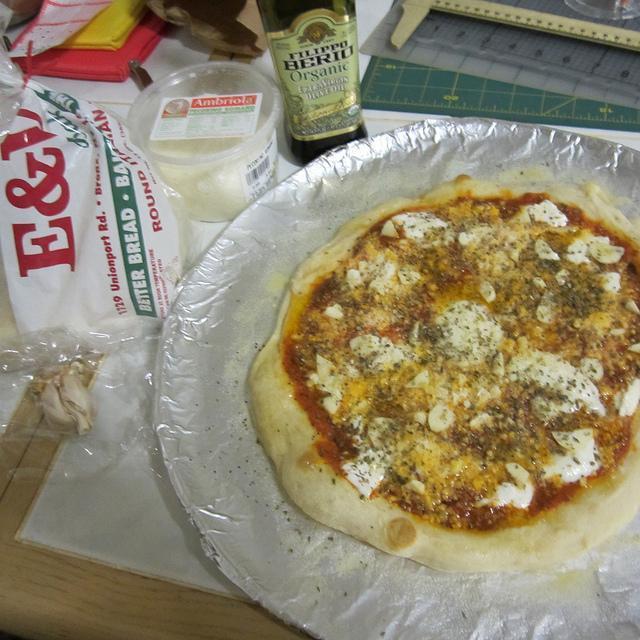How many people are in this photo?
Give a very brief answer. 0. 